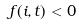Convert formula to latex. <formula><loc_0><loc_0><loc_500><loc_500>f ( i , t ) < 0</formula> 